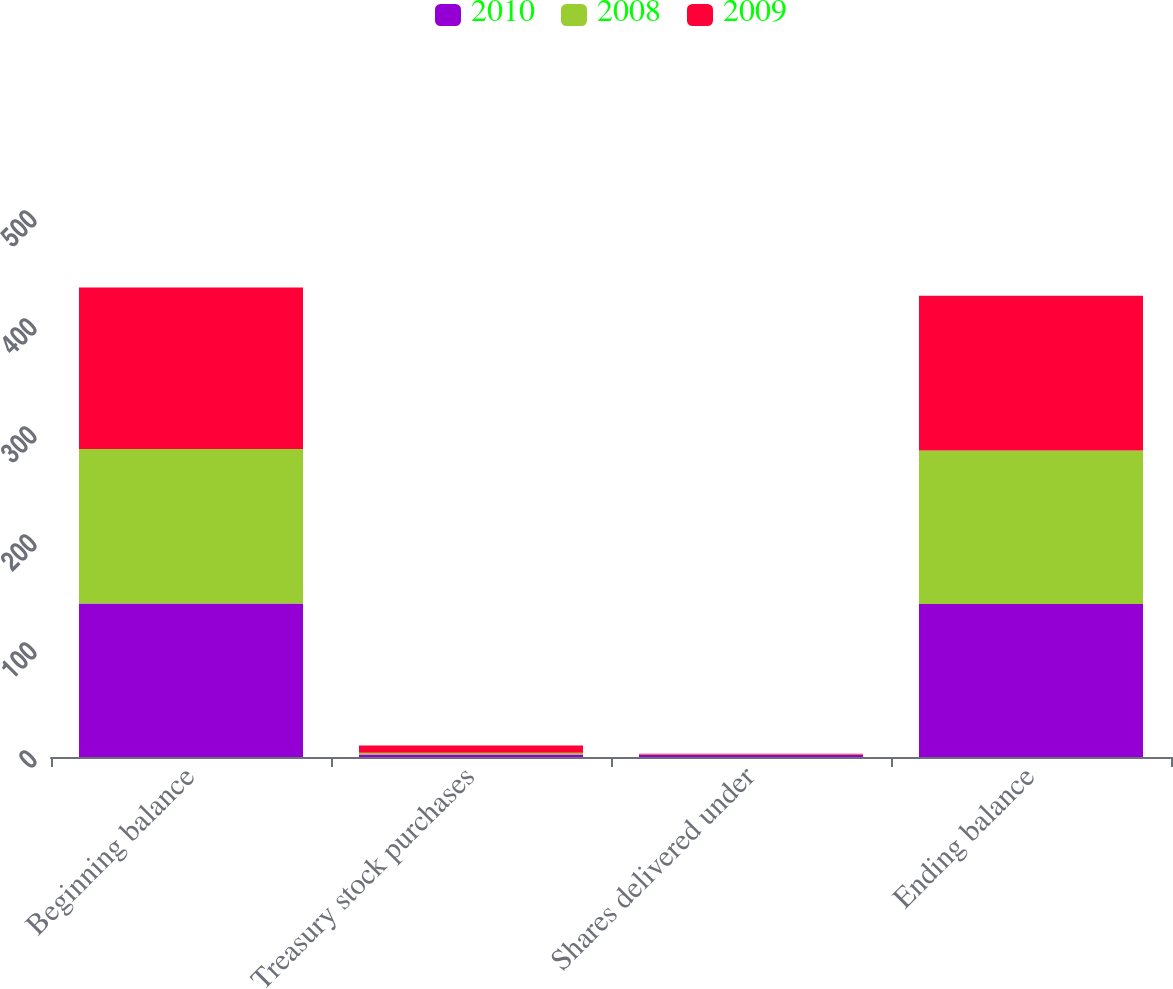<chart> <loc_0><loc_0><loc_500><loc_500><stacked_bar_chart><ecel><fcel>Beginning balance<fcel>Treasury stock purchases<fcel>Shares delivered under<fcel>Ending balance<nl><fcel>2010<fcel>142.1<fcel>2.2<fcel>1.8<fcel>141.7<nl><fcel>2008<fcel>143.2<fcel>1.7<fcel>0.6<fcel>142.1<nl><fcel>2009<fcel>149.4<fcel>6.7<fcel>0.5<fcel>143.2<nl></chart> 